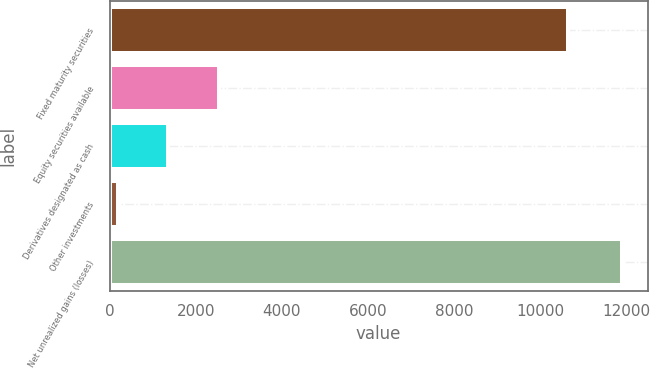Convert chart to OTSL. <chart><loc_0><loc_0><loc_500><loc_500><bar_chart><fcel>Fixed maturity securities<fcel>Equity securities available<fcel>Derivatives designated as cash<fcel>Other investments<fcel>Net unrealized gains (losses)<nl><fcel>10635<fcel>2532.2<fcel>1362.1<fcel>192<fcel>11893<nl></chart> 